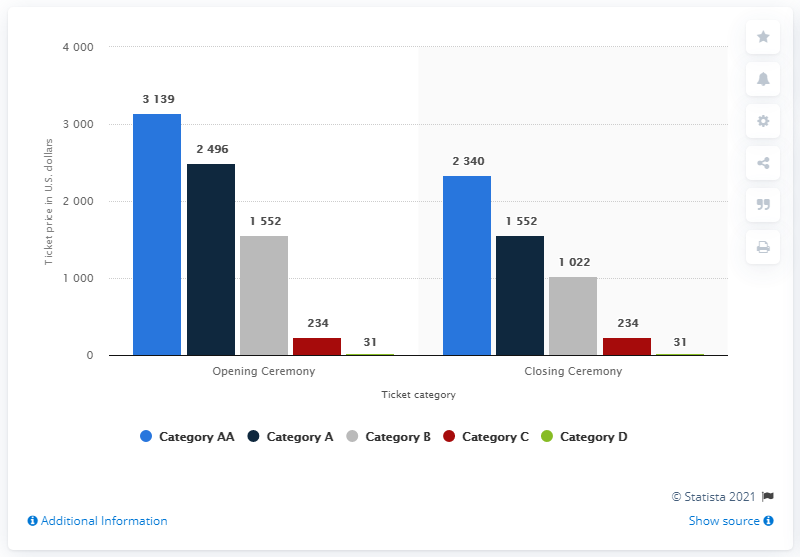Outline some significant characteristics in this image. The closing ceremony ticket in category D cost 31. 